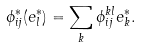<formula> <loc_0><loc_0><loc_500><loc_500>\phi _ { i j } ^ { * } ( e _ { l } ^ { * } ) = \sum _ { k } \phi _ { i j } ^ { k l } e _ { k } ^ { * } .</formula> 